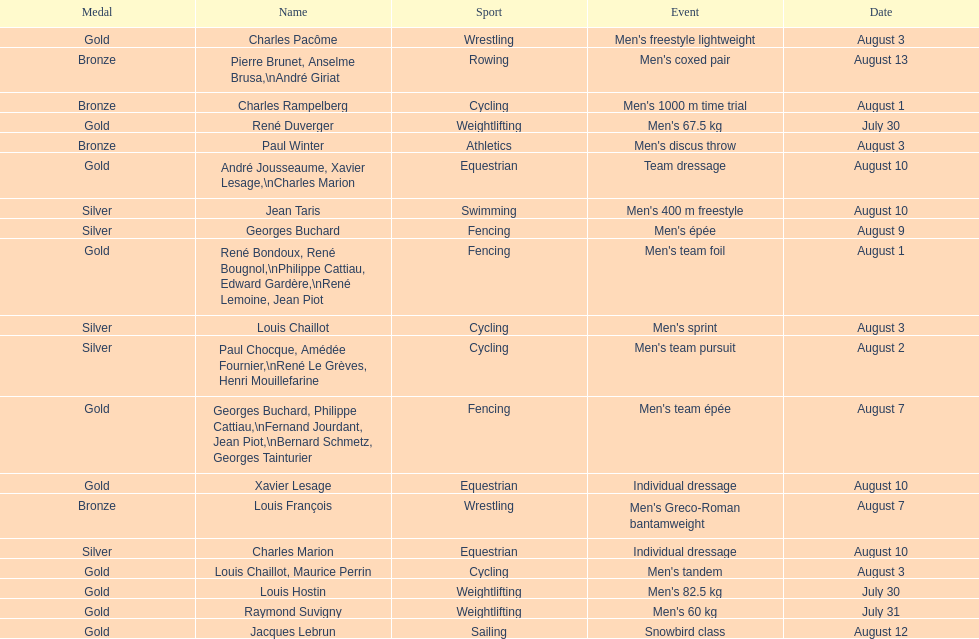How many total gold medals were won by weightlifting? 3. Parse the full table. {'header': ['Medal', 'Name', 'Sport', 'Event', 'Date'], 'rows': [['Gold', 'Charles Pacôme', 'Wrestling', "Men's freestyle lightweight", 'August 3'], ['Bronze', 'Pierre Brunet, Anselme Brusa,\\nAndré Giriat', 'Rowing', "Men's coxed pair", 'August 13'], ['Bronze', 'Charles Rampelberg', 'Cycling', "Men's 1000 m time trial", 'August 1'], ['Gold', 'René Duverger', 'Weightlifting', "Men's 67.5 kg", 'July 30'], ['Bronze', 'Paul Winter', 'Athletics', "Men's discus throw", 'August 3'], ['Gold', 'André Jousseaume, Xavier Lesage,\\nCharles Marion', 'Equestrian', 'Team dressage', 'August 10'], ['Silver', 'Jean Taris', 'Swimming', "Men's 400 m freestyle", 'August 10'], ['Silver', 'Georges Buchard', 'Fencing', "Men's épée", 'August 9'], ['Gold', 'René Bondoux, René Bougnol,\\nPhilippe Cattiau, Edward Gardère,\\nRené Lemoine, Jean Piot', 'Fencing', "Men's team foil", 'August 1'], ['Silver', 'Louis Chaillot', 'Cycling', "Men's sprint", 'August 3'], ['Silver', 'Paul Chocque, Amédée Fournier,\\nRené Le Grèves, Henri Mouillefarine', 'Cycling', "Men's team pursuit", 'August 2'], ['Gold', 'Georges Buchard, Philippe Cattiau,\\nFernand Jourdant, Jean Piot,\\nBernard Schmetz, Georges Tainturier', 'Fencing', "Men's team épée", 'August 7'], ['Gold', 'Xavier Lesage', 'Equestrian', 'Individual dressage', 'August 10'], ['Bronze', 'Louis François', 'Wrestling', "Men's Greco-Roman bantamweight", 'August 7'], ['Silver', 'Charles Marion', 'Equestrian', 'Individual dressage', 'August 10'], ['Gold', 'Louis Chaillot, Maurice Perrin', 'Cycling', "Men's tandem", 'August 3'], ['Gold', 'Louis Hostin', 'Weightlifting', "Men's 82.5 kg", 'July 30'], ['Gold', 'Raymond Suvigny', 'Weightlifting', "Men's 60 kg", 'July 31'], ['Gold', 'Jacques Lebrun', 'Sailing', 'Snowbird class', 'August 12']]} 